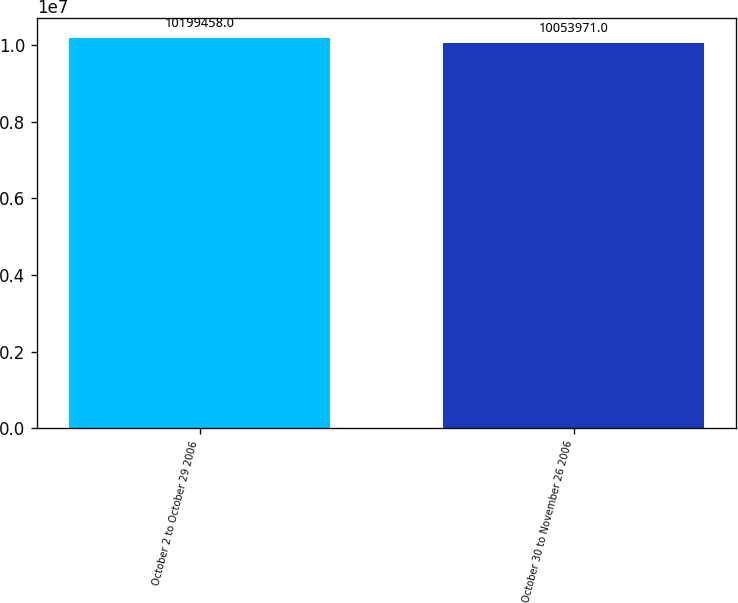<chart> <loc_0><loc_0><loc_500><loc_500><bar_chart><fcel>October 2 to October 29 2006<fcel>October 30 to November 26 2006<nl><fcel>1.01995e+07<fcel>1.0054e+07<nl></chart> 